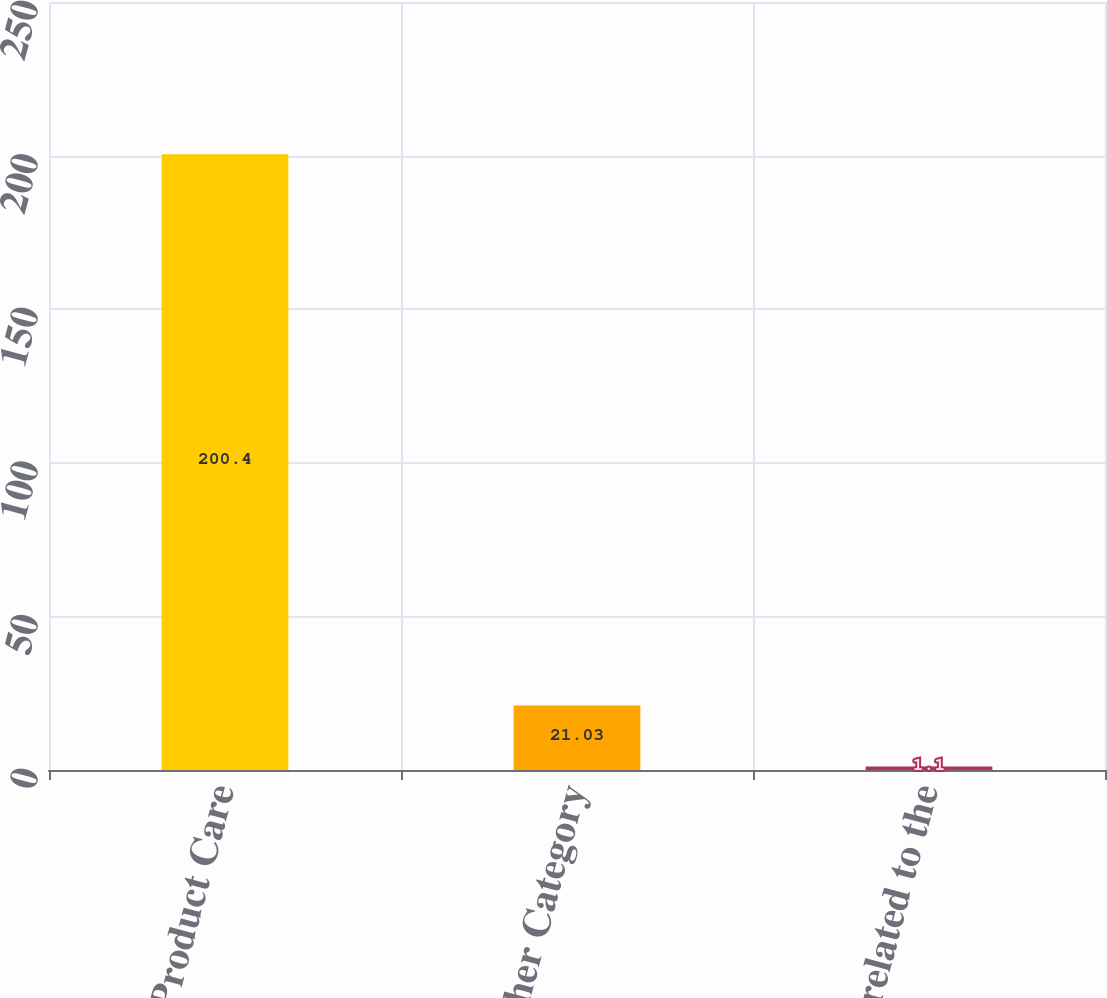Convert chart to OTSL. <chart><loc_0><loc_0><loc_500><loc_500><bar_chart><fcel>Product Care<fcel>Other Category<fcel>Costs related to the<nl><fcel>200.4<fcel>21.03<fcel>1.1<nl></chart> 